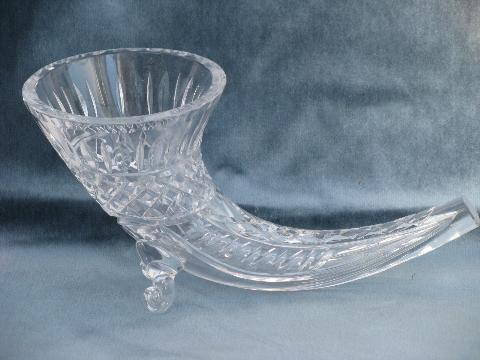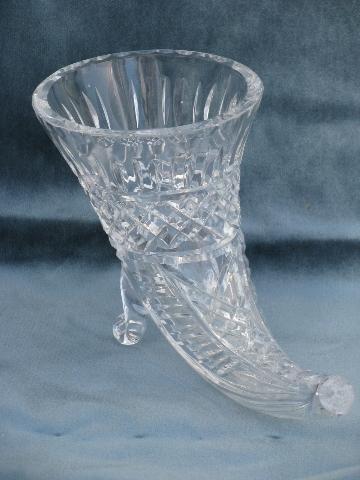The first image is the image on the left, the second image is the image on the right. Examine the images to the left and right. Is the description "The left and right image contains the same number of glass horn vases." accurate? Answer yes or no. Yes. The first image is the image on the left, the second image is the image on the right. Evaluate the accuracy of this statement regarding the images: "There is exactly one curved glass vase is shown in every photograph and in every photo the entire vase is visible.". Is it true? Answer yes or no. Yes. 